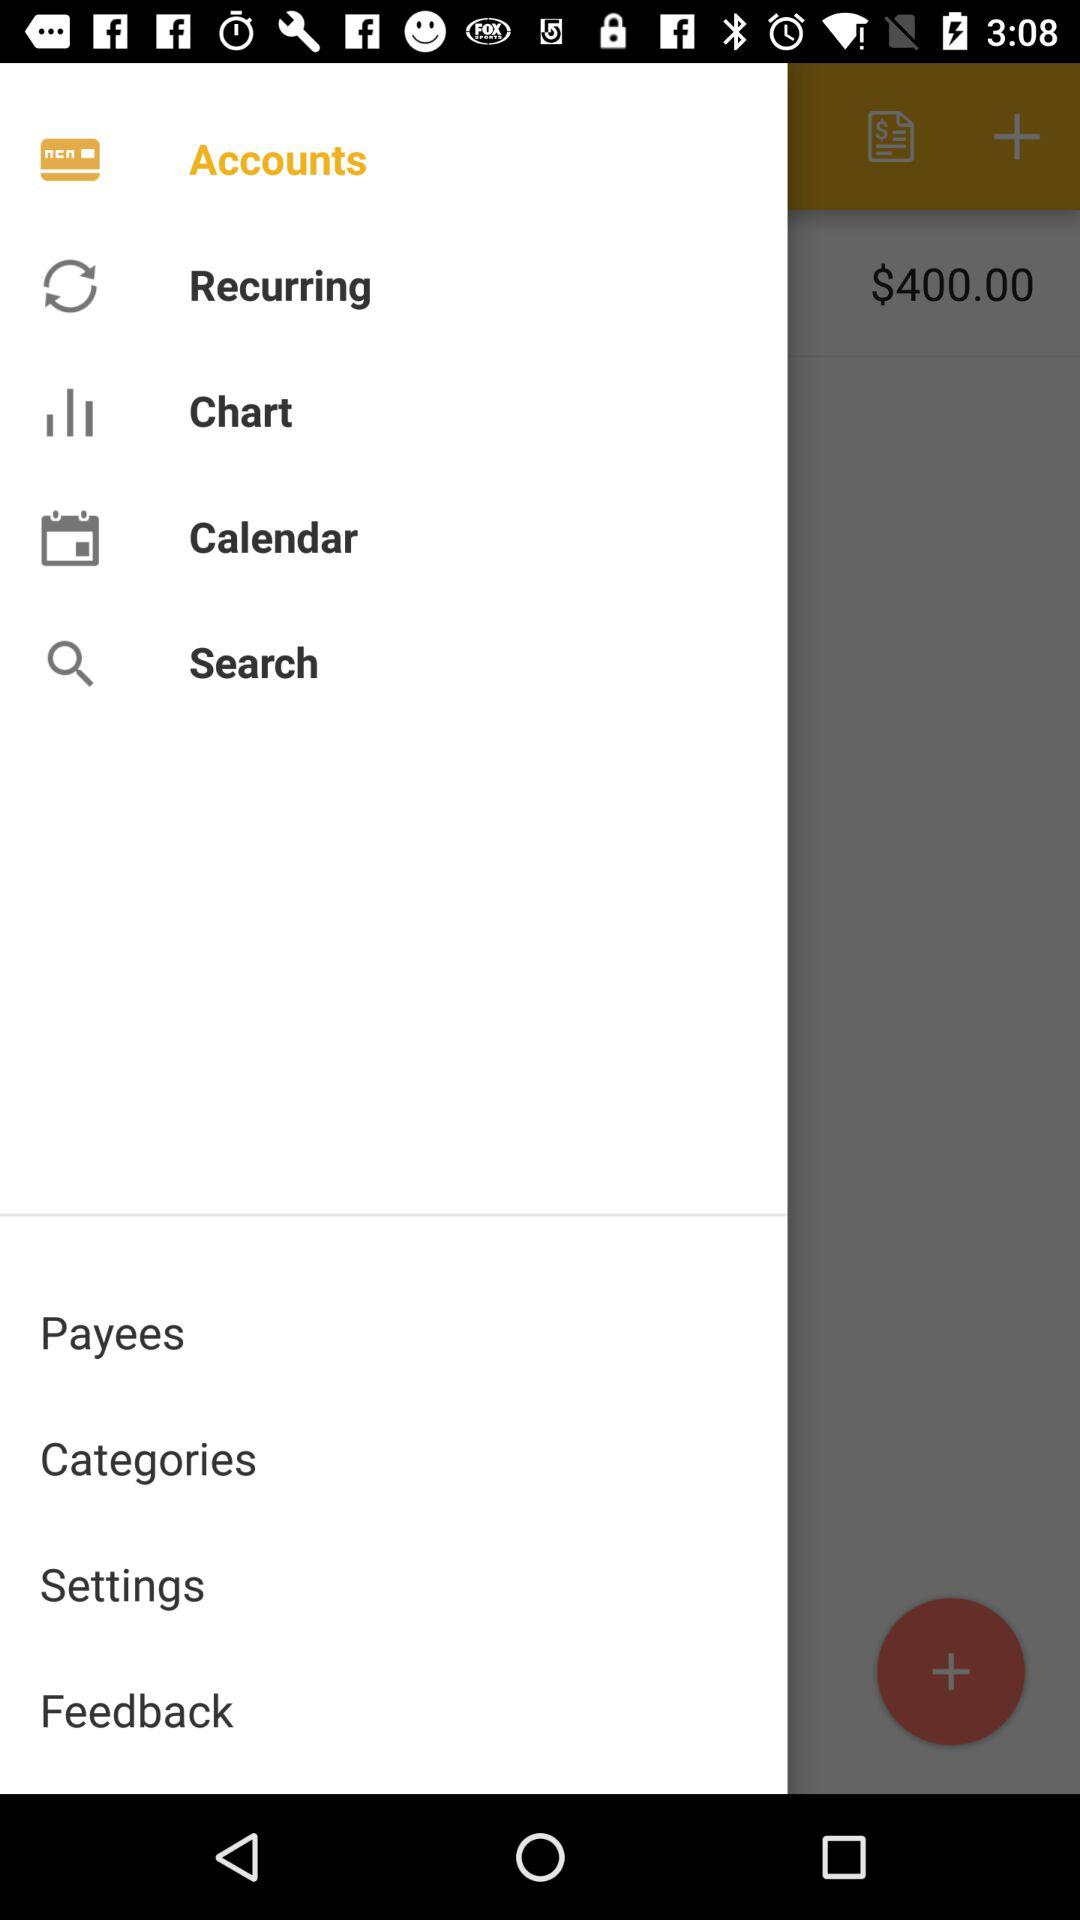How much money is in my account? According to the displayed balance on the mobile banking app, your account currently holds $400.00. It's important to keep track of your account balance to manage your finances effectively. Please remember that any pending transactions may not be reflected in this current balance. 